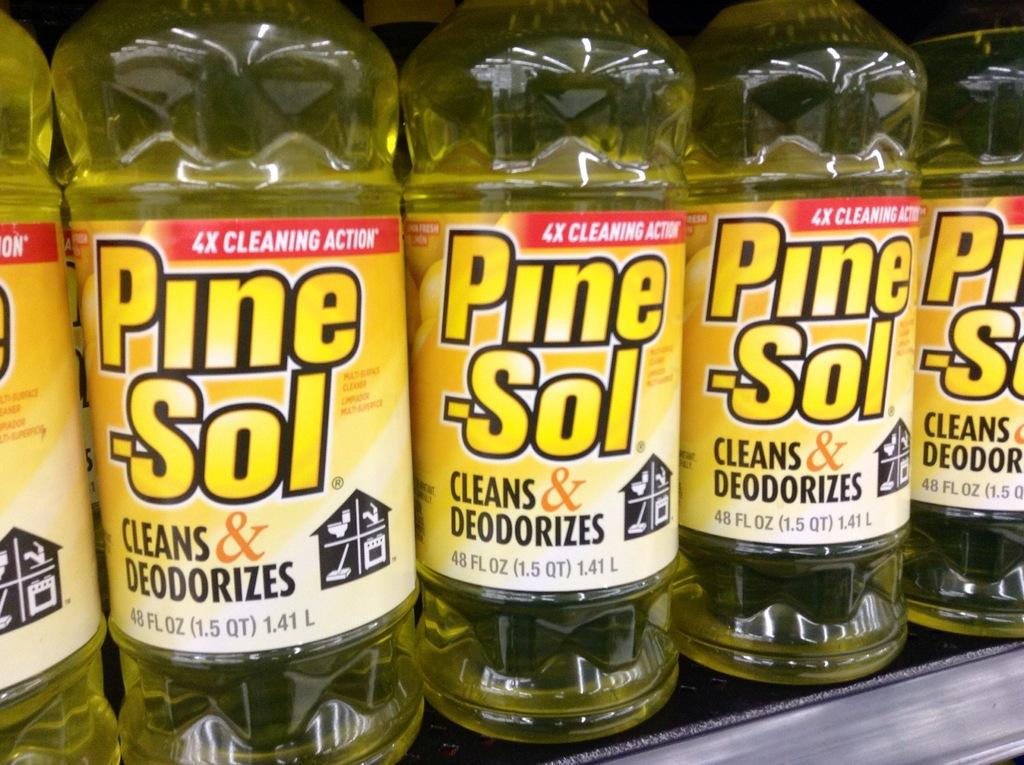<image>
Summarize the visual content of the image. Many bottles of Pine-Sol are next to each other on a shelf. 